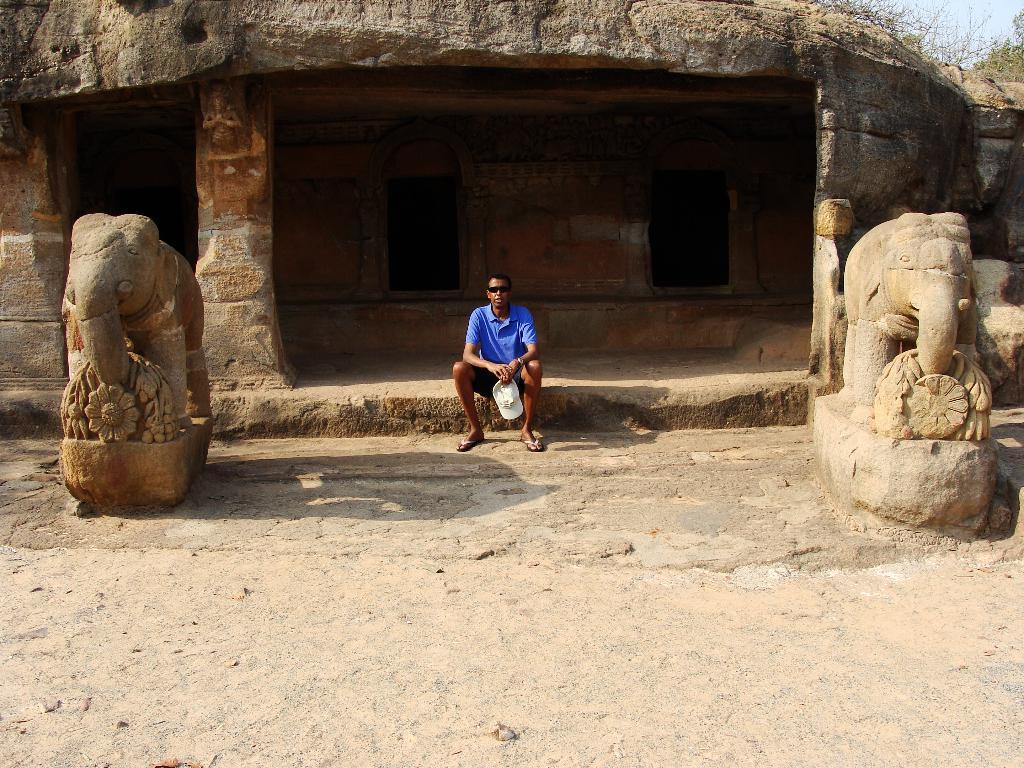What type of home structure is depicted in the image? There is a cave carved as a home structure in the image. What animal-related objects can be seen in the image? There are two elephant statues in the image. Can you describe the person in the image? There is a person sitting in the image. What natural elements are present in the image? There are rocks and plants in the image. What is visible in the background of the image? The sky is visible in the image. What type of advice does the minister give to the person in the image? There is no minister present in the image, so it is not possible to answer that question. 